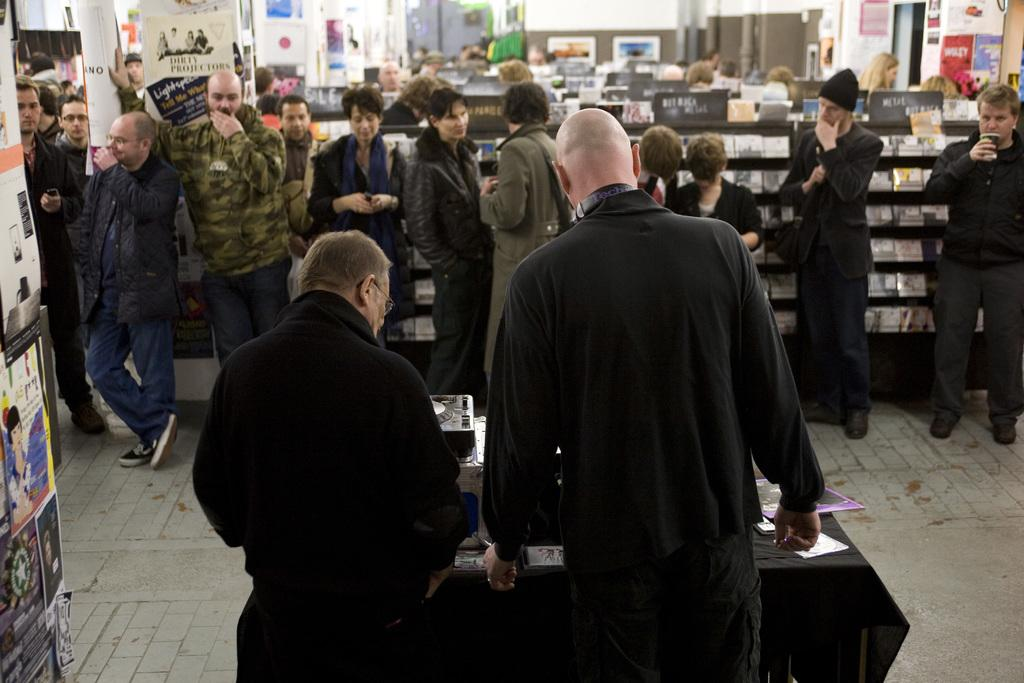What are the people in the image doing? The people in the image are standing. How are the front two people positioned in relation to the table? The front two people are standing in front of a table. What color are the dresses worn by the people in the image? The people are wearing black dresses. What can be seen on the left side of the image? There are posters on the left side of the image. What type of rake is being used by the people in the image? There is no rake present in the image. How many calculators can be seen on the table in the image? There is no calculator visible in the image; only posters are present on the left side of the image. 